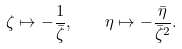<formula> <loc_0><loc_0><loc_500><loc_500>\zeta \mapsto - \frac { 1 } { \bar { \zeta } } , \quad \eta \mapsto - \frac { \bar { \eta } } { \bar { \zeta } ^ { 2 } } .</formula> 